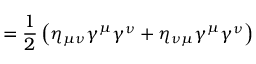Convert formula to latex. <formula><loc_0><loc_0><loc_500><loc_500>= { \frac { 1 } { 2 } } \left ( \eta _ { \mu \nu } \gamma ^ { \mu } \gamma ^ { \nu } + \eta _ { \nu \mu } \gamma ^ { \mu } \gamma ^ { \nu } \right )</formula> 